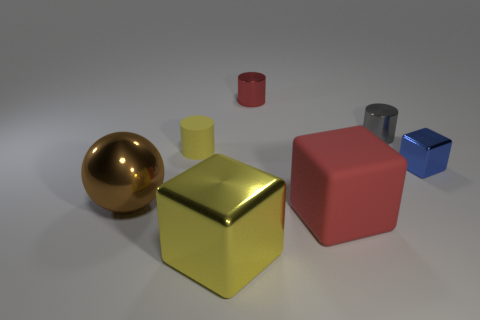What is the material of the gray object that is the same shape as the tiny red object?
Your response must be concise. Metal. What color is the matte thing that is on the left side of the matte object that is to the right of the yellow cube?
Your answer should be very brief. Yellow. What size is the cylinder that is made of the same material as the gray object?
Your answer should be very brief. Small. How many other yellow things are the same shape as the tiny yellow matte thing?
Give a very brief answer. 0. How many objects are either tiny blue shiny objects on the right side of the gray metal thing or big things that are on the right side of the small yellow cylinder?
Keep it short and to the point. 3. How many matte objects are on the right side of the small metal cylinder behind the gray metallic thing?
Provide a short and direct response. 1. Does the metal thing in front of the large brown thing have the same shape as the red thing in front of the shiny sphere?
Offer a terse response. Yes. The big metal object that is the same color as the small matte object is what shape?
Keep it short and to the point. Cube. Are there any tiny gray cylinders made of the same material as the tiny red cylinder?
Offer a terse response. Yes. What number of matte objects are small yellow objects or red objects?
Your answer should be very brief. 2. 